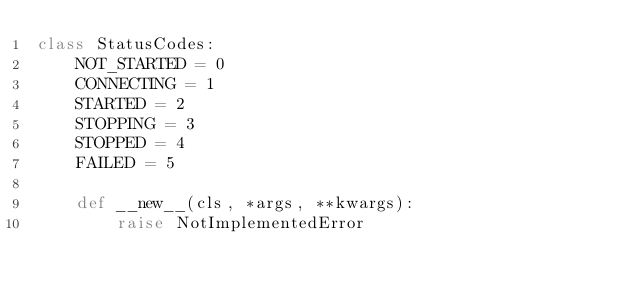Convert code to text. <code><loc_0><loc_0><loc_500><loc_500><_Python_>class StatusCodes:
    NOT_STARTED = 0
    CONNECTING = 1
    STARTED = 2
    STOPPING = 3
    STOPPED = 4
    FAILED = 5

    def __new__(cls, *args, **kwargs):
        raise NotImplementedError
</code> 